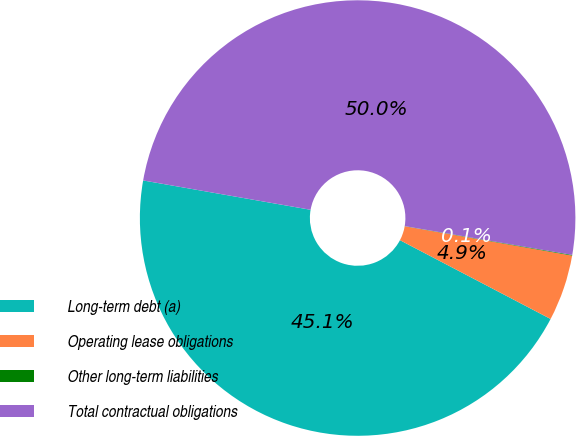Convert chart to OTSL. <chart><loc_0><loc_0><loc_500><loc_500><pie_chart><fcel>Long-term debt (a)<fcel>Operating lease obligations<fcel>Other long-term liabilities<fcel>Total contractual obligations<nl><fcel>45.09%<fcel>4.91%<fcel>0.05%<fcel>49.95%<nl></chart> 